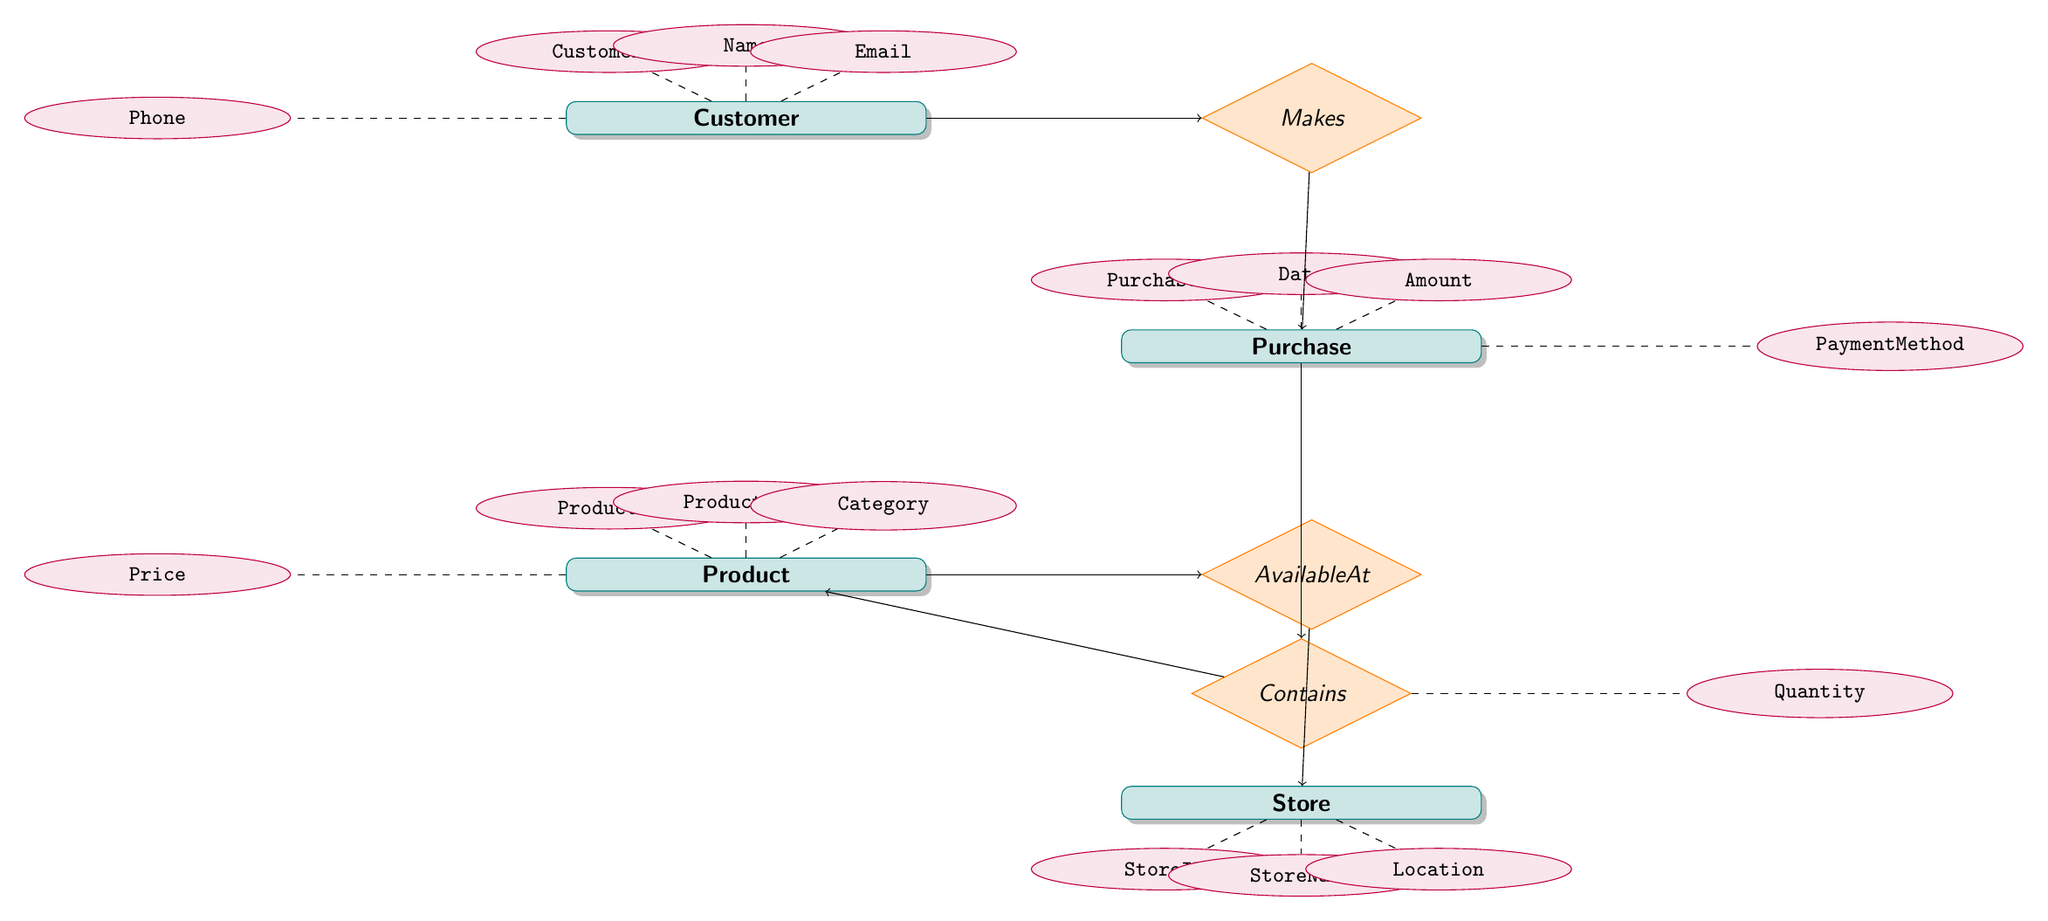What entities are present in the diagram? The diagram shows four entities: Customer, Purchase, Product, and Store.
Answer: Customer, Purchase, Product, Store What is the relationship between Customer and Purchase? The relationship connecting Customer and Purchase is named "Makes."
Answer: Makes How many attributes does the Product entity have? The Product entity has four attributes: ProductID, ProductName, Category, and Price, which counts to four attributes.
Answer: 4 What is the attribute that describes the quantity of products in a Purchase? The attribute related to the quantity of products in a Purchase is labeled "Quantity."
Answer: Quantity Which entity is connected to Store via the AvailableAt relationship? The entity connected to Store via the AvailableAt relationship is Product.
Answer: Product What is the relationship type between Purchase and Product? The relationship type between Purchase and Product is named "Contains."
Answer: Contains What attribute of the Customer entity comes first in the listing? The first attribute in the listing of the Customer entity is "CustomerID."
Answer: CustomerID How many relationships are present in total in the diagram? There are three relationships in total: Makes, Contains, and AvailableAt.
Answer: 3 Which entity has the attribute Price? The attribute Price is associated with the Product entity.
Answer: Product What does the Contains relationship measure? The Contains relationship measures the Quantity of products within a Purchase.
Answer: Quantity 